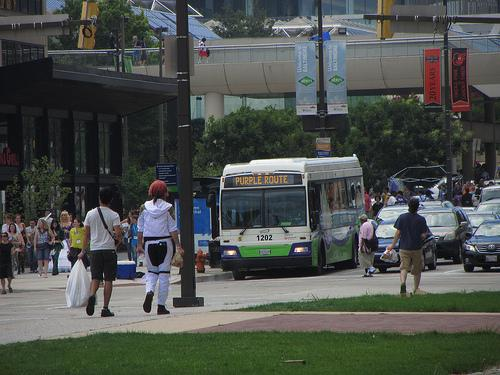How are the traffic lights arranged in the image, and what colors are they? There are two yellow stoplights hanging over the street, one on each side of the city street. What are the two main colors of the advertising banner hanging on the pole? The advertising banner is primarily blue and red. Identify the color and type of the bus in the image. The bus is large, white, and green with blue and green accents. What is the number on the black bus and what is the color of its headlights? The black bus has the number 1202 and its headlights are lit with a white light. What are the main subjects doing in the context of the image? The main subjects are interacting with the city environment, such as walking on the sidewalk, boarding the bus, crossing the street, and driving motor vehicles down the street. Describe the setting in which the image takes place. The image is set in a city street with a brick sidewalk, parked cars, a bridge over the road, street signs, and pedestrians walking or crossing the street. What are the pedestrians doing on the side walk? The pedestrians are walking on the sidewalk, some are crossing the street and one person is boarding a city bus. Describe the scene happening around the fire hydrant. There is a red fire hydrant on the sidewalk with a large white trash bag nearby, a man carrying a plastic bag is walking, and a person in a yellow t-shirt is also present in the scene. What type of clothing is the man wearing who is walking down the sidewalk? The brown-haired man walking down the sidewalk is wearing a blue t-shirt and tan cargo shorts. Mention any anomalies or oddities in the image. A person walking on the green grass in the scene seems a bit odd considering the urban setting. Notice the airplane flying above the bridge. The instruction mentions an airplane which does not exist in the provided objects, making it misleading. Is the man wearing a green t-shirt crossing the street? The language implies there is a man wearing a green t-shirt, while the actual object mentioned in the image is a man wearing a blue t-shirt crossing the street. Observe the tall building right beside the bus. There is no mention of any building in the given image, leading to confusion and distraction. Can you find a bicycle parked near the bus stand? There is no mention of a bicycle in the objects provided in the image, causing confusion on what to look for. Watch out for a blue fire hydrant on the sidewalk. There is no blue fire hydrant mentioned in the image, but rather a red fire hydrant, making this instruction misleading. Look for a dog playing on the sidewalk. There is no mention of a dog in the given image, making this instruction misleading and irrelevant to the objects present. Is there a boy skateboarding on the brick city sidewalk? There is no mention of a boy skateboarding in the image, causing the viewer to look for something that does not exist. Does the lady have an umbrella while walking down the sidewalk? There is no mention of a lady with an umbrella in the given objects, making this instruction misleading and potentially confusing for the viewer. Does the green and white bus have a pink and yellow stripe? There is no mention of a pink and yellow stripe on the green and white bus in the image, causing false expectations. Find the orange traffic cone in the intersection. An orange traffic cone is not present in the objects, leading to confusion while searching for it. 